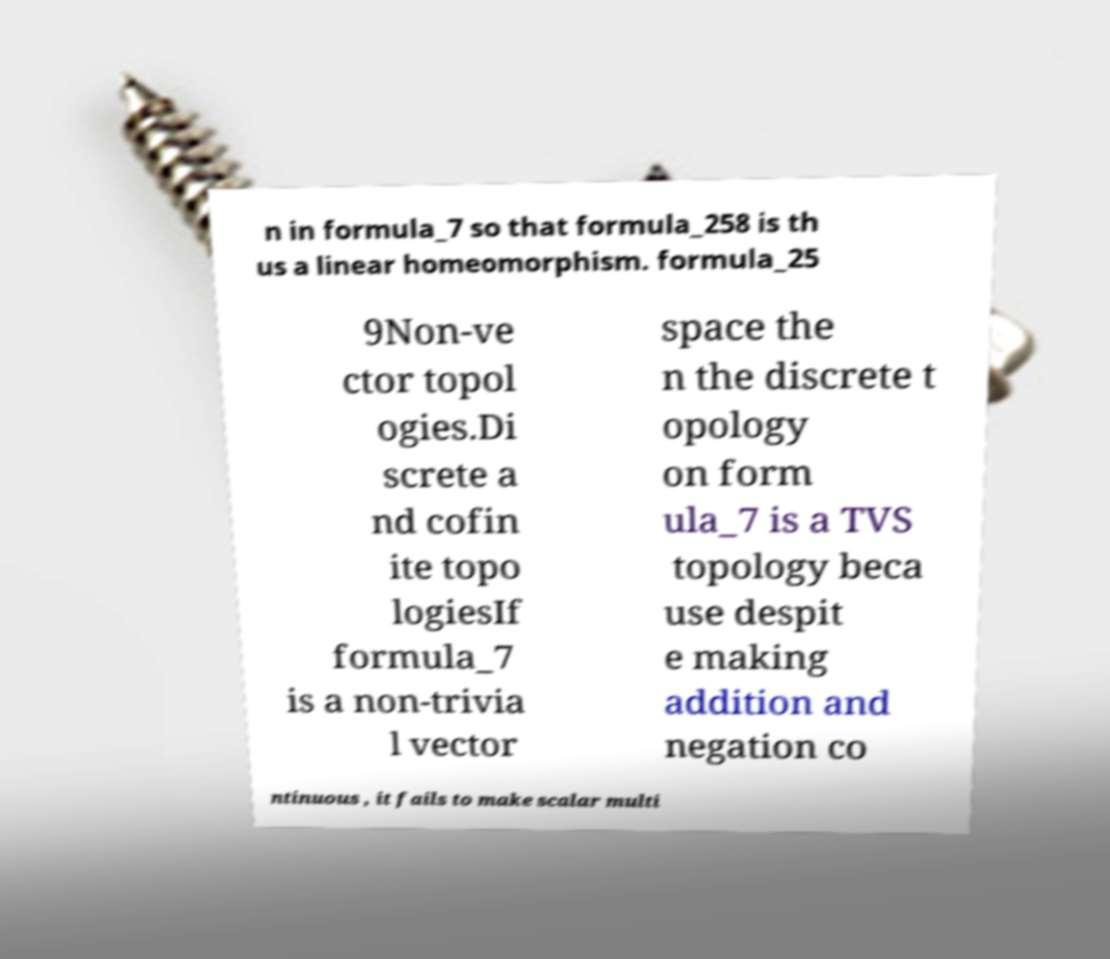Please read and relay the text visible in this image. What does it say? n in formula_7 so that formula_258 is th us a linear homeomorphism. formula_25 9Non-ve ctor topol ogies.Di screte a nd cofin ite topo logiesIf formula_7 is a non-trivia l vector space the n the discrete t opology on form ula_7 is a TVS topology beca use despit e making addition and negation co ntinuous , it fails to make scalar multi 